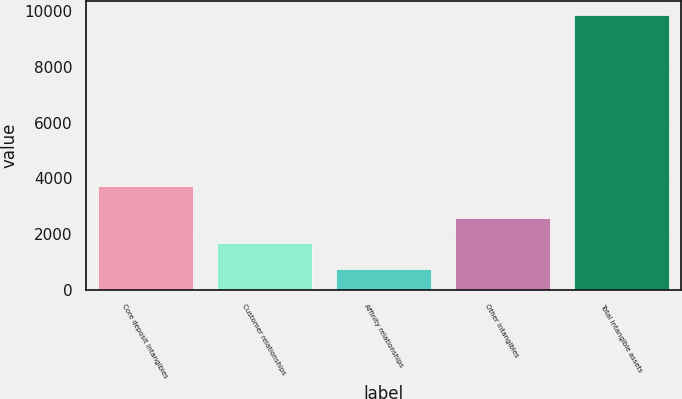<chart> <loc_0><loc_0><loc_500><loc_500><bar_chart><fcel>Core deposit intangibles<fcel>Customer relationships<fcel>Affinity relationships<fcel>Other intangibles<fcel>Total intangible assets<nl><fcel>3722<fcel>1662.7<fcel>751<fcel>2574.4<fcel>9868<nl></chart> 